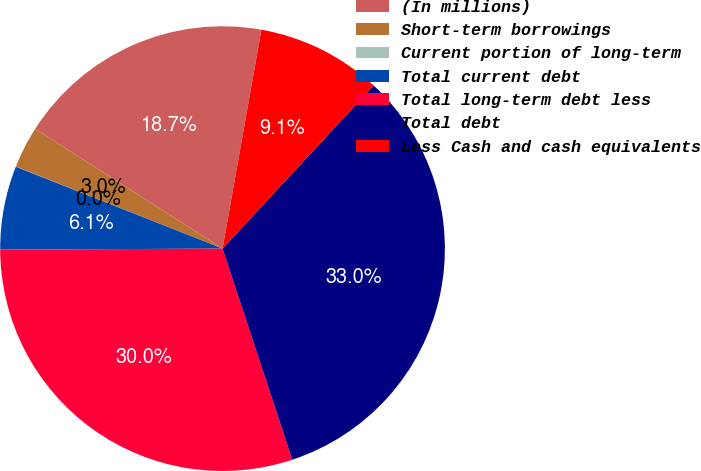Convert chart. <chart><loc_0><loc_0><loc_500><loc_500><pie_chart><fcel>(In millions)<fcel>Short-term borrowings<fcel>Current portion of long-term<fcel>Total current debt<fcel>Total long-term debt less<fcel>Total debt<fcel>Less Cash and cash equivalents<nl><fcel>18.74%<fcel>3.04%<fcel>0.02%<fcel>6.07%<fcel>30.01%<fcel>33.03%<fcel>9.09%<nl></chart> 